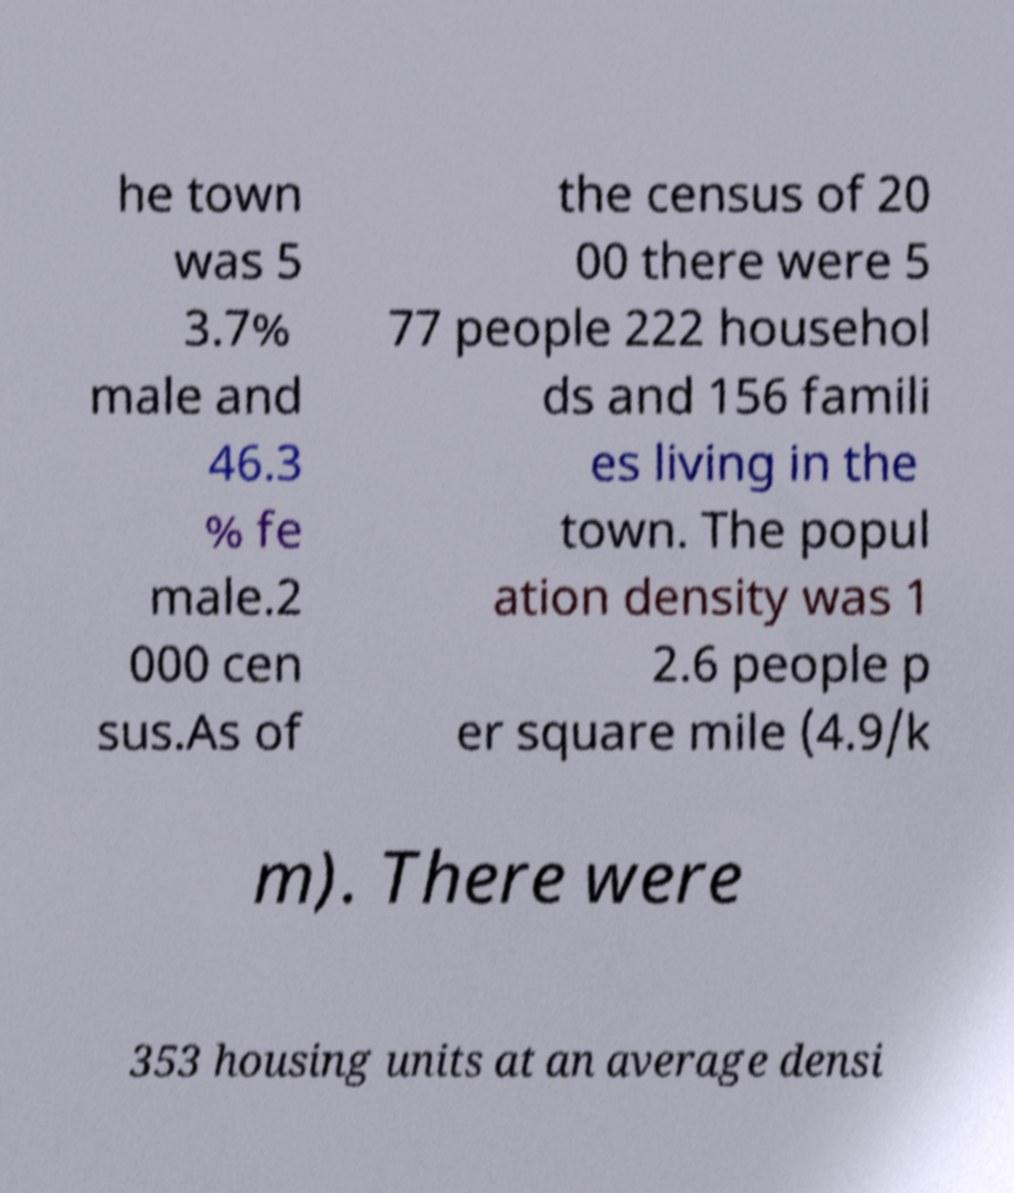Could you assist in decoding the text presented in this image and type it out clearly? he town was 5 3.7% male and 46.3 % fe male.2 000 cen sus.As of the census of 20 00 there were 5 77 people 222 househol ds and 156 famili es living in the town. The popul ation density was 1 2.6 people p er square mile (4.9/k m). There were 353 housing units at an average densi 